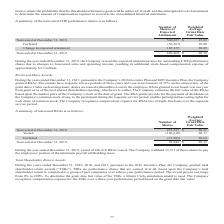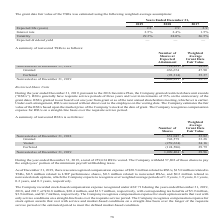According to Aci Worldwide's financial document, What are TSRs? performance shares that are earned, if at all, based upon the Company’s total shareholder return as compared to a group of peer companies over a three-year performance period.. The document states: "total shareholder return awards (“TSRs”). TSRs are performance shares that are earned, if at all, based upon the Company’s total shareholder return as..." Also, What was the interest rate in 2017? According to the financial document, 1.5%. The relevant text states: "Interest rate 2.5 % 2.4 % 1.5 %..." Also, What was the volatility in 2018? According to the financial document, 28.0%. The relevant text states: "Volatility 29.3 % 28.0 % 26.5 %..." Also, can you calculate: What was the change in interest rate between 2018 and 2019? Based on the calculation: 2.5%-2.4%, the result is 0.1 (percentage). This is based on the information: "Interest rate 2.5 % 2.4 % 1.5 % Interest rate 2.5 % 2.4 % 1.5 %..." The key data points involved are: 2.4, 2.5. Also, can you calculate: What was the change in Volatility between 2017 and 2018? Based on the calculation: 28.0%-26.5%, the result is 1.5 (percentage). This is based on the information: "Volatility 29.3 % 28.0 % 26.5 % Volatility 29.3 % 28.0 % 26.5 %..." The key data points involved are: 26.5, 28.0. Also, can you calculate: What was the percentage change in expected life (years) between 2018 and 2019? To answer this question, I need to perform calculations using the financial data. The calculation is: (2.8-2.9)/2.9, which equals -3.45 (percentage). This is based on the information: "Expected life (years) 2.8 2.9 2.9 Expected life (years) 2.8 2.9 2.9..." The key data points involved are: 2.8, 2.9. 